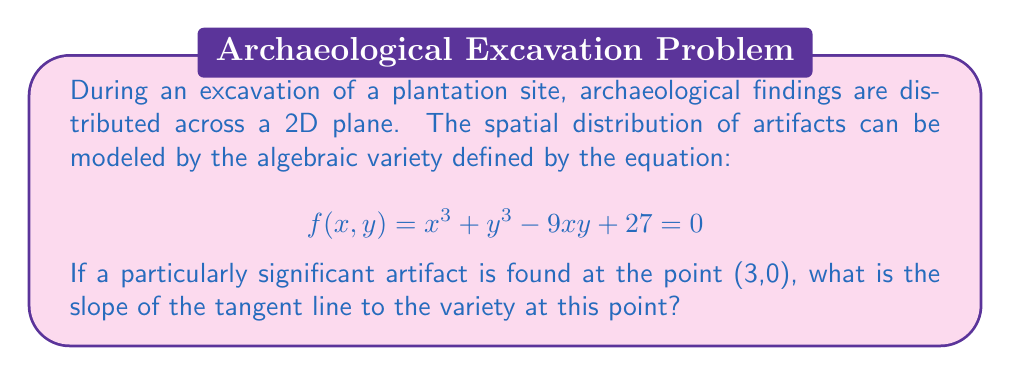Help me with this question. To find the slope of the tangent line at the point (3,0), we need to follow these steps:

1) First, we need to find the partial derivatives of $f(x,y)$ with respect to $x$ and $y$:

   $\frac{\partial f}{\partial x} = 3x^2 - 9y$
   $\frac{\partial f}{\partial y} = 3y^2 - 9x$

2) The slope of the tangent line at any point $(x,y)$ is given by:

   $\text{slope} = -\frac{\frac{\partial f}{\partial x}}{\frac{\partial f}{\partial y}}$

3) Now, we evaluate these partial derivatives at the point (3,0):

   $\frac{\partial f}{\partial x}|_{(3,0)} = 3(3)^2 - 9(0) = 27$
   $\frac{\partial f}{\partial y}|_{(3,0)} = 3(0)^2 - 9(3) = -27$

4) Substituting these values into our slope formula:

   $\text{slope} = -\frac{27}{-27} = 1$

Therefore, the slope of the tangent line to the variety at the point (3,0) is 1.
Answer: 1 